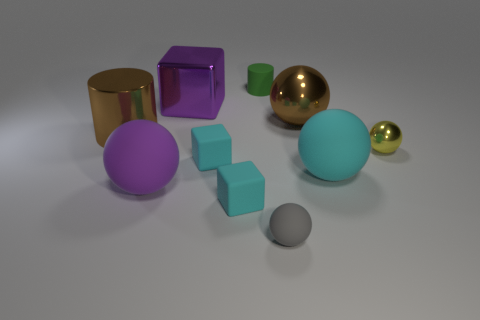Subtract all large cyan rubber spheres. How many spheres are left? 4 Subtract all blocks. How many objects are left? 7 Subtract all large purple matte objects. Subtract all big brown cylinders. How many objects are left? 8 Add 3 purple objects. How many purple objects are left? 5 Add 1 tiny blocks. How many tiny blocks exist? 3 Subtract 0 gray cubes. How many objects are left? 10 